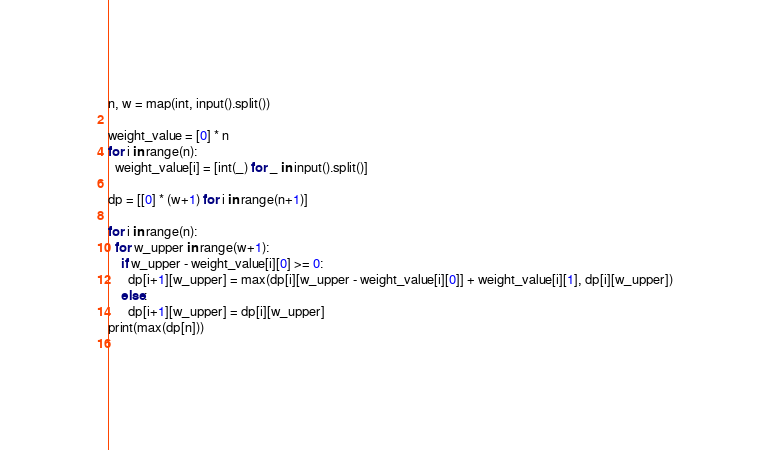<code> <loc_0><loc_0><loc_500><loc_500><_Python_>n, w = map(int, input().split())

weight_value = [0] * n
for i in range(n):
  weight_value[i] = [int(_) for _ in input().split()]
  
dp = [[0] * (w+1) for i in range(n+1)]

for i in range(n):
  for w_upper in range(w+1):
    if w_upper - weight_value[i][0] >= 0:
      dp[i+1][w_upper] = max(dp[i][w_upper - weight_value[i][0]] + weight_value[i][1], dp[i][w_upper])
    else:
      dp[i+1][w_upper] = dp[i][w_upper]
print(max(dp[n]))
      </code> 